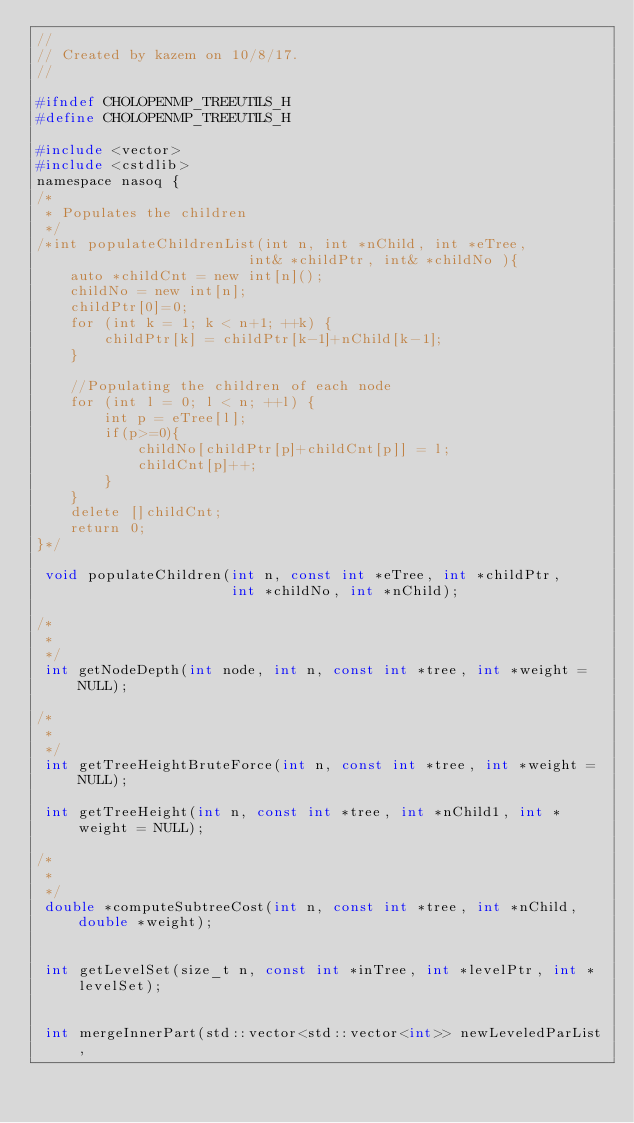Convert code to text. <code><loc_0><loc_0><loc_500><loc_500><_C_>//
// Created by kazem on 10/8/17.
//

#ifndef CHOLOPENMP_TREEUTILS_H
#define CHOLOPENMP_TREEUTILS_H

#include <vector>
#include <cstdlib>
namespace nasoq {
/*
 * Populates the children
 */
/*int populateChildrenList(int n, int *nChild, int *eTree,
                         int& *childPtr, int& *childNo ){
    auto *childCnt = new int[n]();
    childNo = new int[n];
    childPtr[0]=0;
    for (int k = 1; k < n+1; ++k) {
        childPtr[k] = childPtr[k-1]+nChild[k-1];
    }

    //Populating the children of each node
    for (int l = 0; l < n; ++l) {
        int p = eTree[l];
        if(p>=0){
            childNo[childPtr[p]+childCnt[p]] = l;
            childCnt[p]++;
        }
    }
    delete []childCnt;
    return 0;
}*/

 void populateChildren(int n, const int *eTree, int *childPtr,
                       int *childNo, int *nChild);

/*
 *
 */
 int getNodeDepth(int node, int n, const int *tree, int *weight = NULL);

/*
 *
 */
 int getTreeHeightBruteForce(int n, const int *tree, int *weight = NULL);

 int getTreeHeight(int n, const int *tree, int *nChild1, int *weight = NULL);

/*
 *
 */
 double *computeSubtreeCost(int n, const int *tree, int *nChild, double *weight);


 int getLevelSet(size_t n, const int *inTree, int *levelPtr, int *levelSet);


 int mergeInnerPart(std::vector<std::vector<int>> newLeveledParList,</code> 